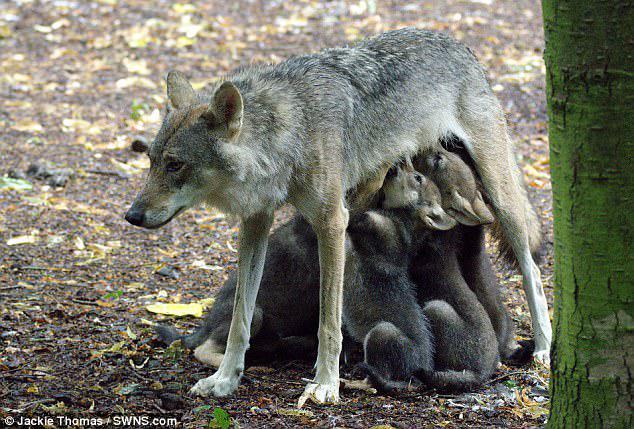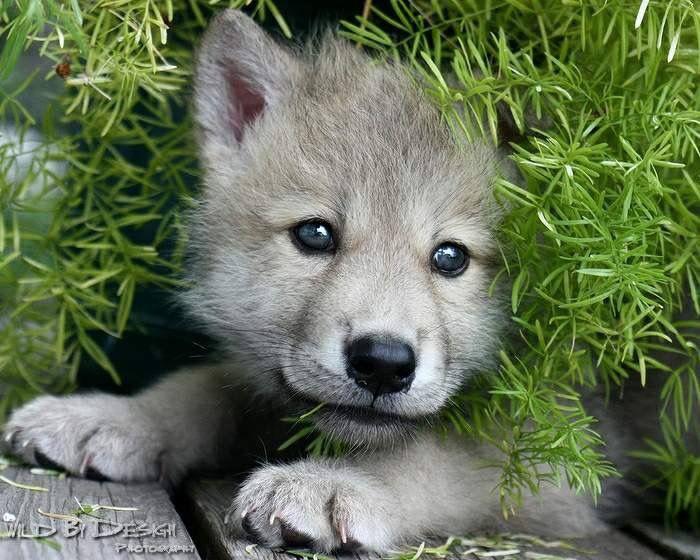The first image is the image on the left, the second image is the image on the right. Assess this claim about the two images: "One image shows no adult wolves, and the other image shows a standing adult wolf with multiple pups.". Correct or not? Answer yes or no. Yes. The first image is the image on the left, the second image is the image on the right. Assess this claim about the two images: "Several pups are nursing in the image on the left.". Correct or not? Answer yes or no. Yes. 